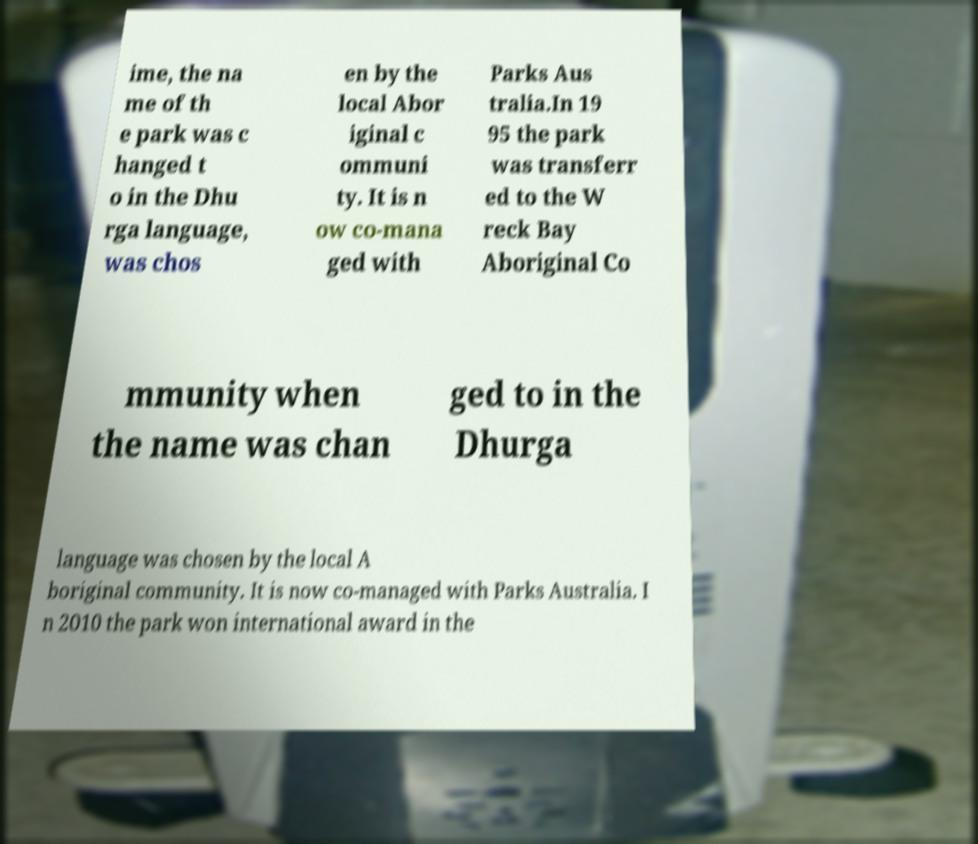Could you extract and type out the text from this image? ime, the na me of th e park was c hanged t o in the Dhu rga language, was chos en by the local Abor iginal c ommuni ty. It is n ow co-mana ged with Parks Aus tralia.In 19 95 the park was transferr ed to the W reck Bay Aboriginal Co mmunity when the name was chan ged to in the Dhurga language was chosen by the local A boriginal community. It is now co-managed with Parks Australia. I n 2010 the park won international award in the 